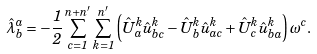Convert formula to latex. <formula><loc_0><loc_0><loc_500><loc_500>\hat { \lambda } ^ { a } _ { b } = - \frac { 1 } { 2 } \sum _ { c = 1 } ^ { n + n ^ { \prime } } \sum _ { k = 1 } ^ { n ^ { \prime } } \left ( \hat { U } ^ { k } _ { a } \hat { u } ^ { k } _ { b c } - \hat { U } ^ { k } _ { b } \hat { u } ^ { k } _ { a c } + \hat { U } ^ { k } _ { c } \hat { u } ^ { k } _ { b a } \right ) \omega ^ { c } .</formula> 